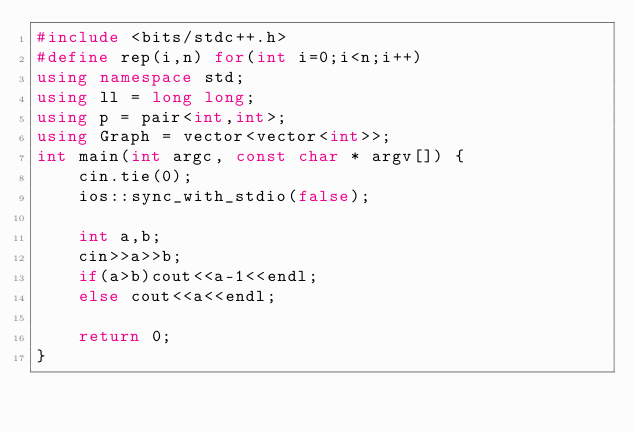<code> <loc_0><loc_0><loc_500><loc_500><_C++_>#include <bits/stdc++.h>
#define rep(i,n) for(int i=0;i<n;i++)
using namespace std;
using ll = long long;
using p = pair<int,int>;
using Graph = vector<vector<int>>;
int main(int argc, const char * argv[]) {
    cin.tie(0);
    ios::sync_with_stdio(false);

    int a,b;
    cin>>a>>b;
    if(a>b)cout<<a-1<<endl;
    else cout<<a<<endl;

    return 0;
}</code> 